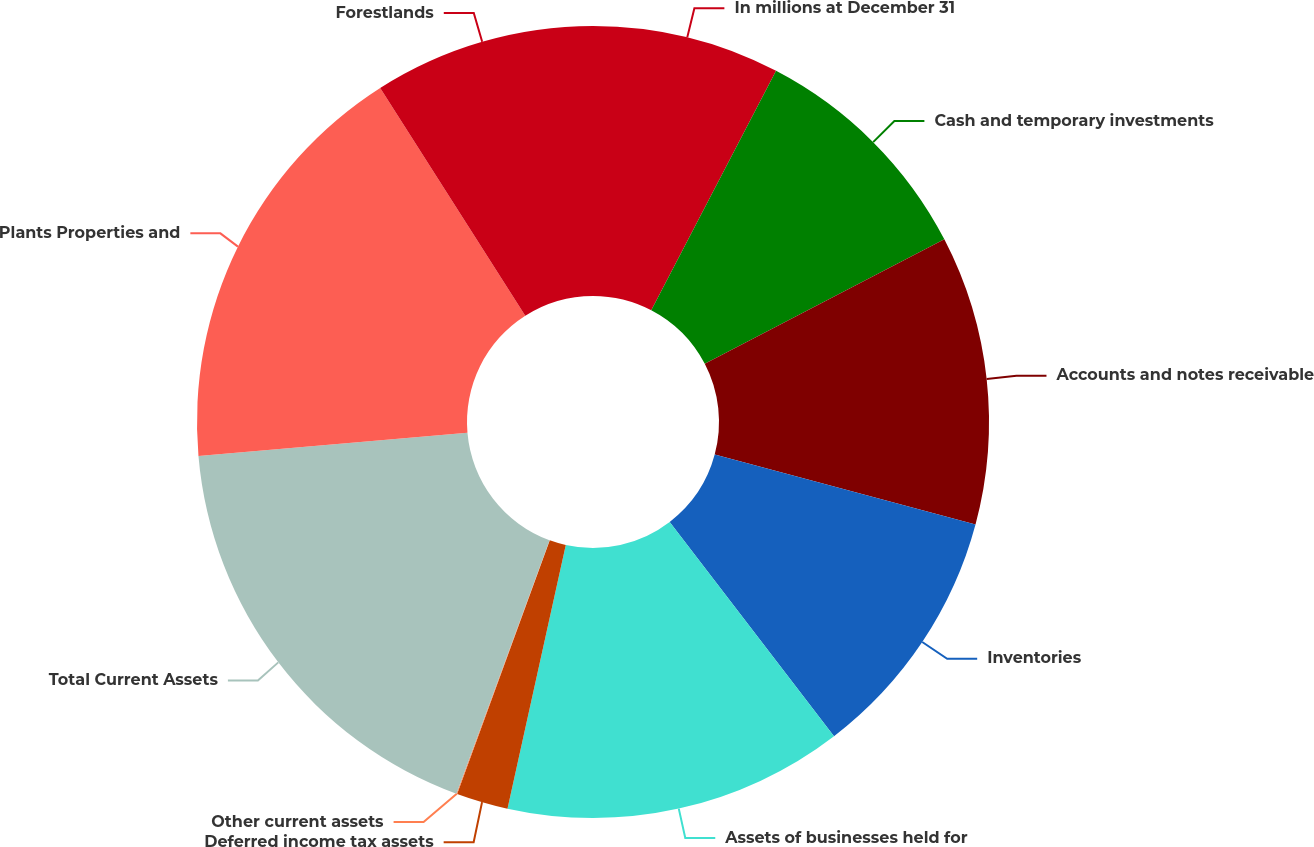Convert chart. <chart><loc_0><loc_0><loc_500><loc_500><pie_chart><fcel>In millions at December 31<fcel>Cash and temporary investments<fcel>Accounts and notes receivable<fcel>Inventories<fcel>Assets of businesses held for<fcel>Deferred income tax assets<fcel>Other current assets<fcel>Total Current Assets<fcel>Plants Properties and<fcel>Forestlands<nl><fcel>7.65%<fcel>9.72%<fcel>11.8%<fcel>10.42%<fcel>13.88%<fcel>2.11%<fcel>0.03%<fcel>18.03%<fcel>17.34%<fcel>9.03%<nl></chart> 